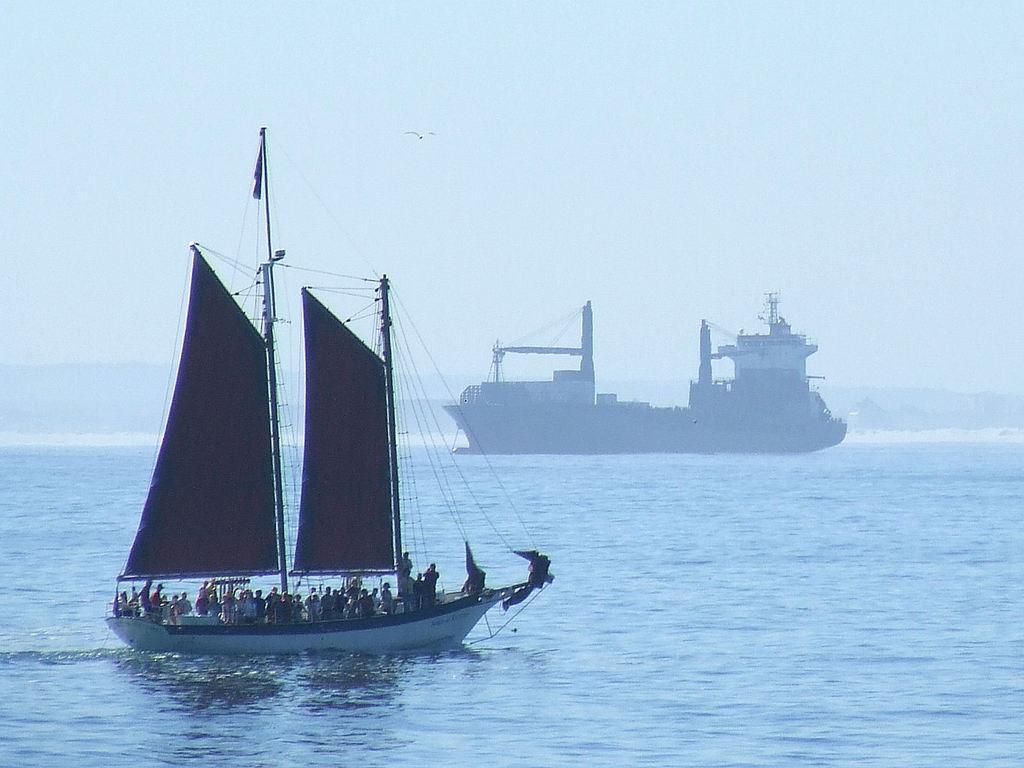Can you describe this image briefly? In this image I can see a boat on the water. I can also see few persons in the boat, background I can see the sky in blue color. 